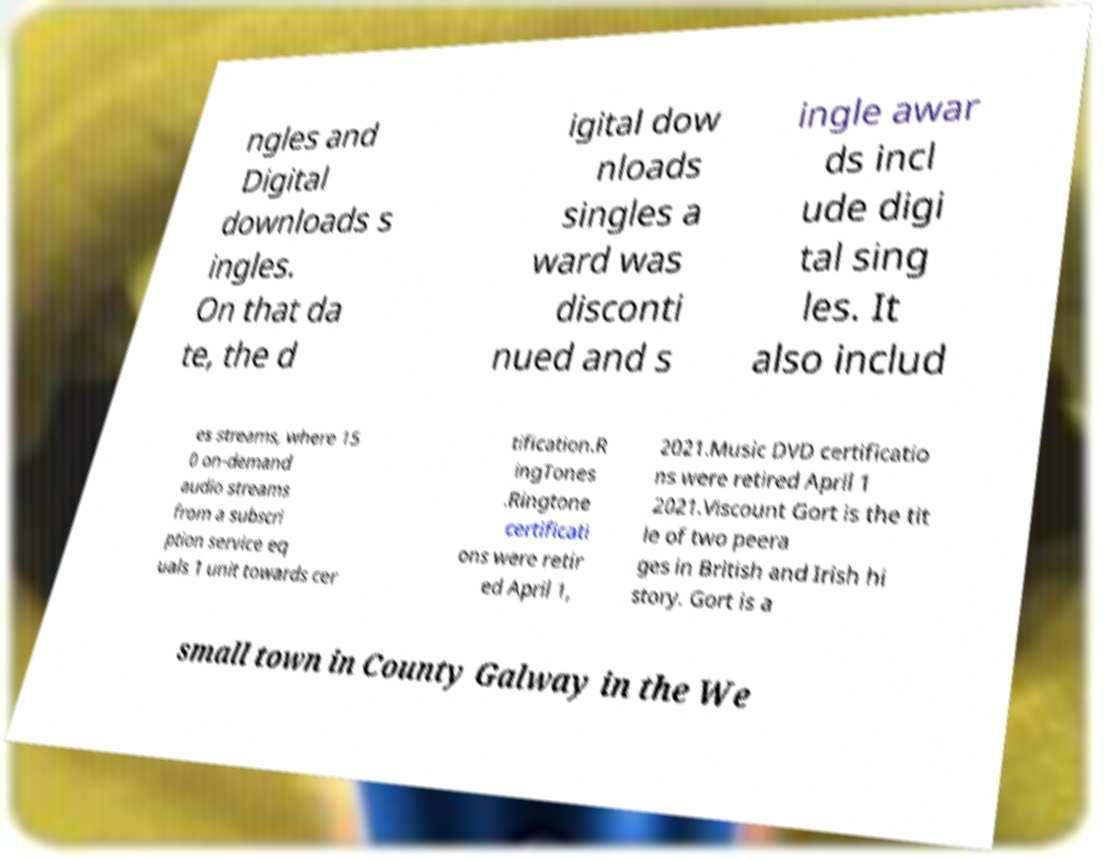I need the written content from this picture converted into text. Can you do that? ngles and Digital downloads s ingles. On that da te, the d igital dow nloads singles a ward was disconti nued and s ingle awar ds incl ude digi tal sing les. It also includ es streams, where 15 0 on-demand audio streams from a subscri ption service eq uals 1 unit towards cer tification.R ingTones .Ringtone certificati ons were retir ed April 1, 2021.Music DVD certificatio ns were retired April 1 2021.Viscount Gort is the tit le of two peera ges in British and Irish hi story. Gort is a small town in County Galway in the We 